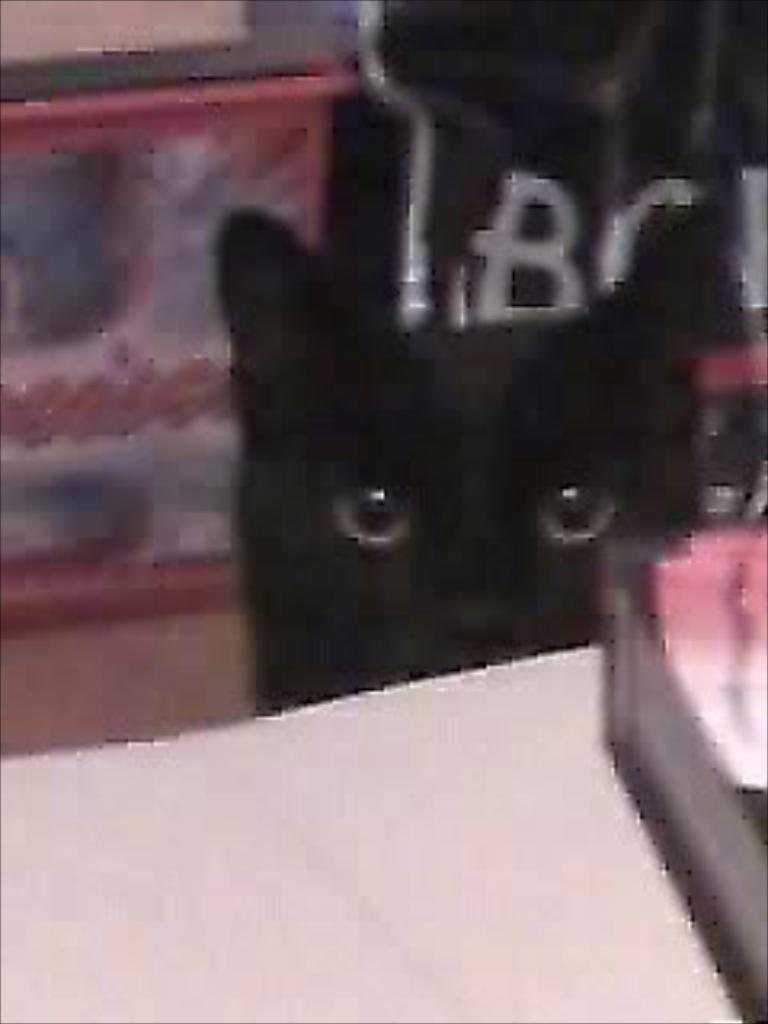What type of animal is present in the image? There is a cat in the image. Can you describe the appearance of the cat in the image? The cat is blurry in the background. What type of finger can be seen in the image? There is no finger present in the image; it features a cat that is blurry in the background. 